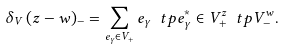Convert formula to latex. <formula><loc_0><loc_0><loc_500><loc_500>\delta _ { V } \, ( { z - w } ) _ { - } = \sum _ { e _ { \gamma } \in V _ { + } } e _ { \gamma } \ t p e _ { \gamma } ^ { * } \in V _ { + } ^ { z } \ t p V _ { - } ^ { w } .</formula> 